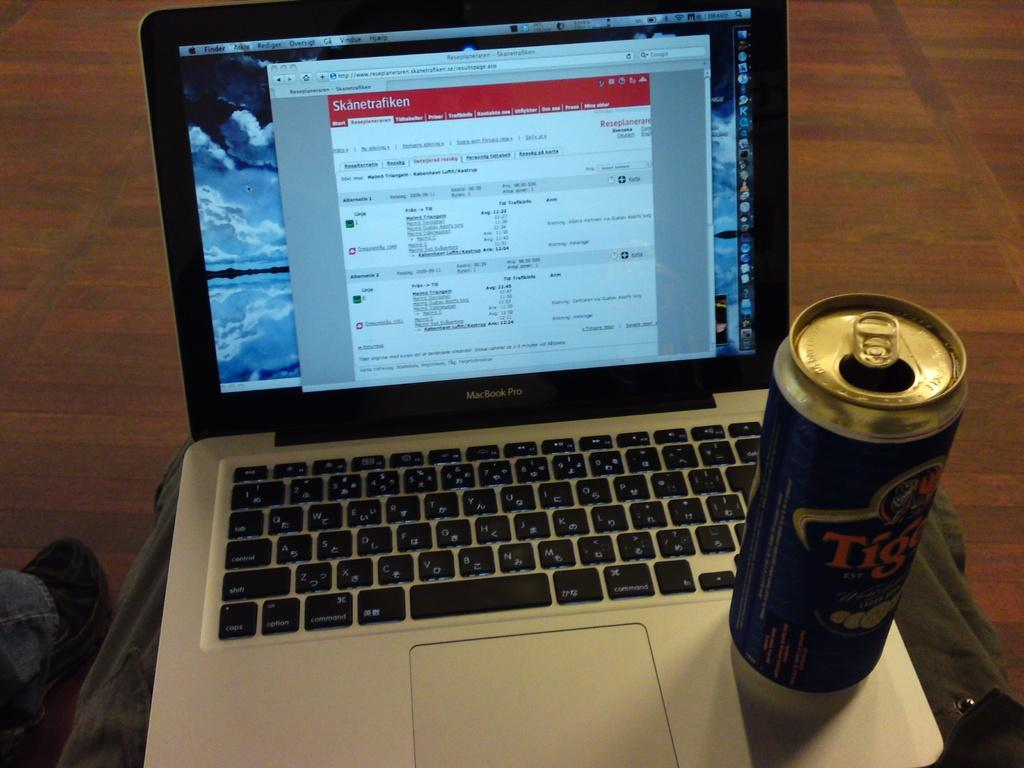<image>
Give a short and clear explanation of the subsequent image. A laptop that says MacBook Pro has a can of beer on the keyboard. 